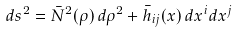<formula> <loc_0><loc_0><loc_500><loc_500>d s ^ { 2 } = \bar { N } ^ { 2 } ( \rho ) \, d \rho ^ { 2 } + \bar { h } _ { i j } ( x ) \, d x ^ { i } d x ^ { j }</formula> 